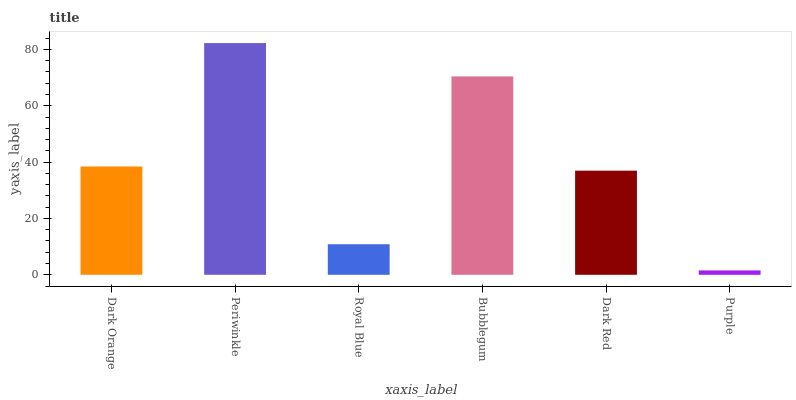Is Purple the minimum?
Answer yes or no. Yes. Is Periwinkle the maximum?
Answer yes or no. Yes. Is Royal Blue the minimum?
Answer yes or no. No. Is Royal Blue the maximum?
Answer yes or no. No. Is Periwinkle greater than Royal Blue?
Answer yes or no. Yes. Is Royal Blue less than Periwinkle?
Answer yes or no. Yes. Is Royal Blue greater than Periwinkle?
Answer yes or no. No. Is Periwinkle less than Royal Blue?
Answer yes or no. No. Is Dark Orange the high median?
Answer yes or no. Yes. Is Dark Red the low median?
Answer yes or no. Yes. Is Purple the high median?
Answer yes or no. No. Is Purple the low median?
Answer yes or no. No. 